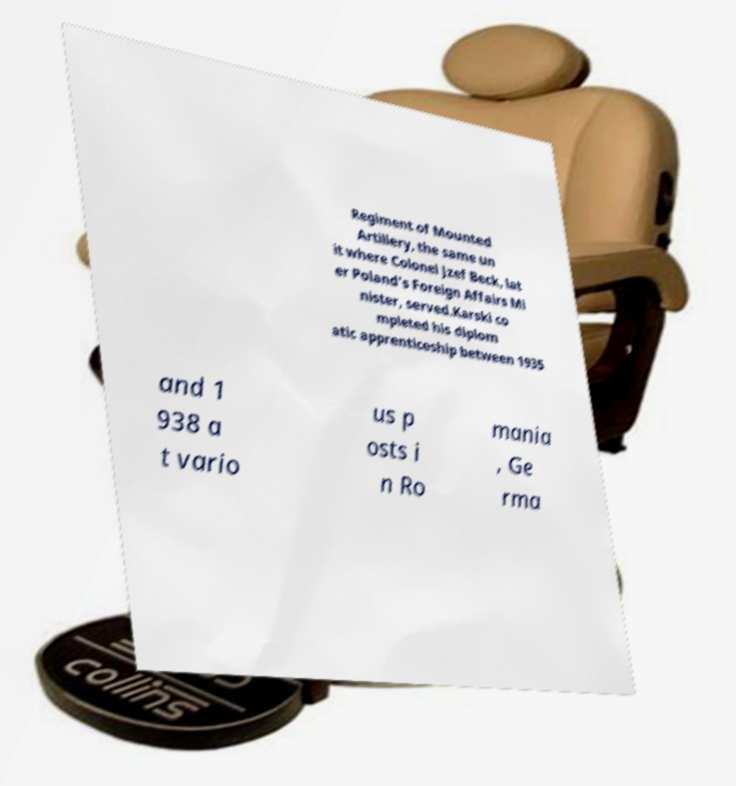For documentation purposes, I need the text within this image transcribed. Could you provide that? Regiment of Mounted Artillery, the same un it where Colonel Jzef Beck, lat er Poland's Foreign Affairs Mi nister, served.Karski co mpleted his diplom atic apprenticeship between 1935 and 1 938 a t vario us p osts i n Ro mania , Ge rma 